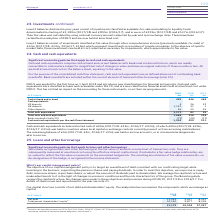From Bt Group Plc's financial document, What was the cash at bank and in hand in 2019, 2018 and 2017? The document contains multiple relevant values: 495, 446, 469 (in millions). From the document: "Cash at bank and in hand 495 446 469 Cash equivalents US deposits 3 26 32 UK deposits 1,132 31 1 Other deposits 36 25 26 Cash at bank and in hand 495 ..." Also, What was the balance held in escrow account in 2019? According to the financial document, £4m. The relevant text states: "accessing cash balances. The remaining balance of £4m (2017/18: £3m, 2016/17: £2m) was held in escrow accounts, or in commercial arrangements akin to escr..." Also, When was the IFRS 9 applied? According to the financial document, 1 April 2018. The relevant text states: "IFRS 9 was applied for the first time on 1 April 2018 and introduces new classifications for financial instruments. Cash and cash equivalents were classi..." Also, can you calculate: What is the change in the Cash at bank and in hand from 2018 to 2019? Based on the calculation: 495 - 446, the result is 49 (in millions). This is based on the information: "Cash at bank and in hand 495 446 469 Cash equivalents US deposits 3 26 32 UK deposits 1,132 31 1 Other deposits 36 25 26 Cash at bank and in hand 495 446 469 Cash equivalents US deposits 3 26 32 UK de..." The key data points involved are: 446, 495. Also, can you calculate: What is the average US deposits for 2017-2019? To answer this question, I need to perform calculations using the financial data. The calculation is: (3 + 26 + 32) / 3, which equals 20.33 (in millions). This is based on the information: "n hand 495 446 469 Cash equivalents US deposits 3 26 32 UK deposits 1,132 31 1 Other deposits 36 25 26 and 495 446 469 Cash equivalents US deposits 3 26 32 UK deposits 1,132 31 1 Other deposits 36 25 ..." The key data points involved are: 26, 32. Additionally, For which year(s) are the Total cash and cash equivalents lower than 1,000 million? The document shows two values: 2018 and 2017 (in millions). From the document: "At 31 March 2019 £m 2018 £m 2017 £m At 31 March 2019 £m 2018 £m 2017 £m..." 